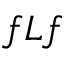Convert formula to latex. <formula><loc_0><loc_0><loc_500><loc_500>f L f</formula> 